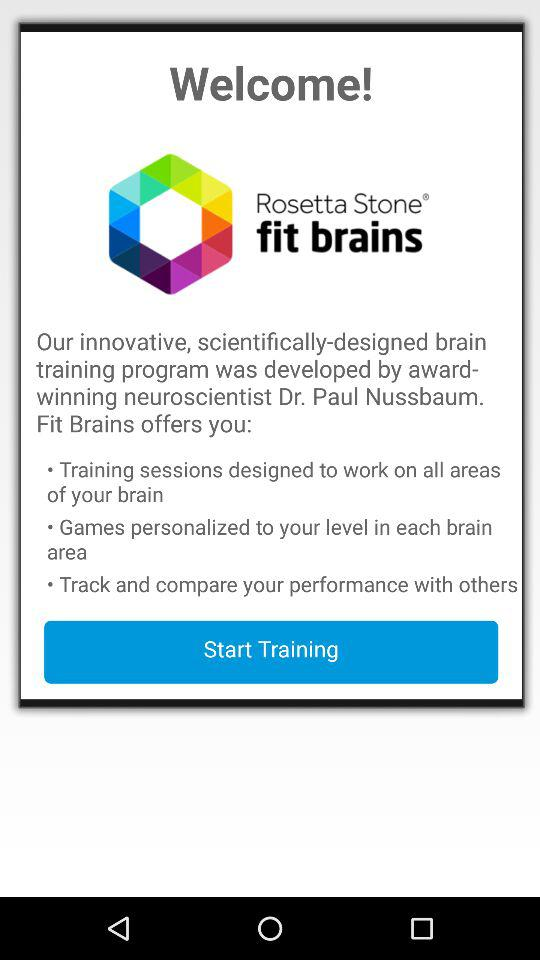What is the name of the application? The name of the application is "Rosetta Stone fit brains". 